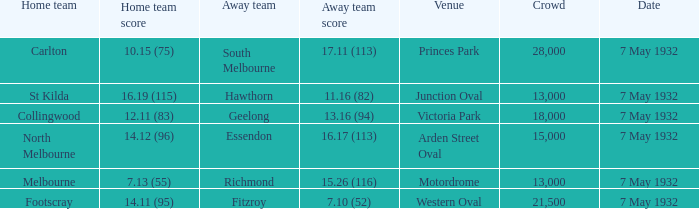What is the total of crowd with Home team score of 14.12 (96)? 15000.0. 